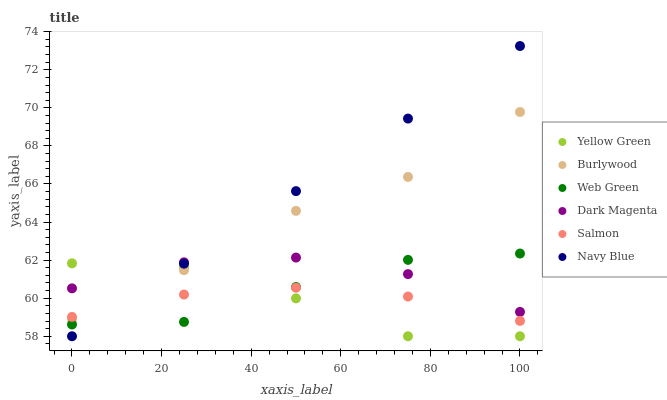Does Yellow Green have the minimum area under the curve?
Answer yes or no. Yes. Does Navy Blue have the maximum area under the curve?
Answer yes or no. Yes. Does Burlywood have the minimum area under the curve?
Answer yes or no. No. Does Burlywood have the maximum area under the curve?
Answer yes or no. No. Is Navy Blue the smoothest?
Answer yes or no. Yes. Is Yellow Green the roughest?
Answer yes or no. Yes. Is Burlywood the smoothest?
Answer yes or no. No. Is Burlywood the roughest?
Answer yes or no. No. Does Yellow Green have the lowest value?
Answer yes or no. Yes. Does Burlywood have the lowest value?
Answer yes or no. No. Does Navy Blue have the highest value?
Answer yes or no. Yes. Does Burlywood have the highest value?
Answer yes or no. No. Is Web Green less than Burlywood?
Answer yes or no. Yes. Is Dark Magenta greater than Salmon?
Answer yes or no. Yes. Does Web Green intersect Dark Magenta?
Answer yes or no. Yes. Is Web Green less than Dark Magenta?
Answer yes or no. No. Is Web Green greater than Dark Magenta?
Answer yes or no. No. Does Web Green intersect Burlywood?
Answer yes or no. No. 